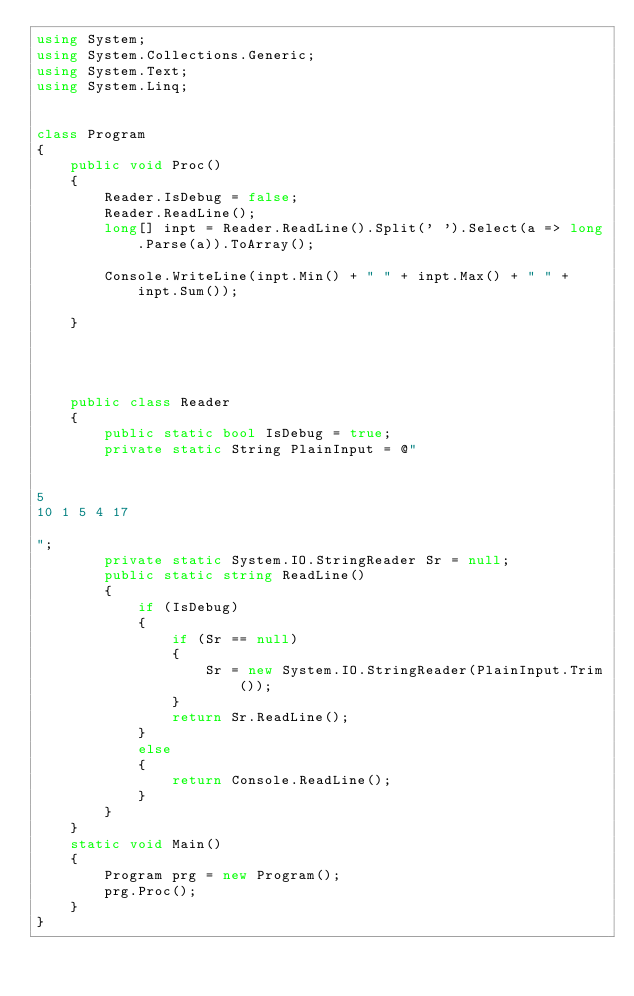<code> <loc_0><loc_0><loc_500><loc_500><_C#_>using System;
using System.Collections.Generic;
using System.Text;
using System.Linq;


class Program
{
    public void Proc()
    {
        Reader.IsDebug = false;
        Reader.ReadLine();
        long[] inpt = Reader.ReadLine().Split(' ').Select(a => long.Parse(a)).ToArray();

        Console.WriteLine(inpt.Min() + " " + inpt.Max() + " " + inpt.Sum());
    
    }




    public class Reader
    {
        public static bool IsDebug = true;
        private static String PlainInput = @"


5
10 1 5 4 17

";
        private static System.IO.StringReader Sr = null;
        public static string ReadLine()
        {
            if (IsDebug)
            {
                if (Sr == null)
                {
                    Sr = new System.IO.StringReader(PlainInput.Trim());
                }
                return Sr.ReadLine();
            }
            else
            {
                return Console.ReadLine();
            }
        }
    }
    static void Main()
    {
        Program prg = new Program();
        prg.Proc();
    }
}</code> 